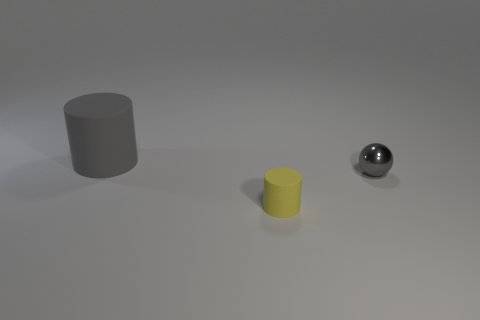Is there anything else that has the same material as the small sphere?
Offer a terse response. No. What color is the thing to the right of the matte thing that is right of the matte thing behind the gray ball?
Ensure brevity in your answer.  Gray. Is the small cylinder made of the same material as the object to the right of the tiny yellow rubber cylinder?
Keep it short and to the point. No. There is another thing that is the same shape as the yellow rubber thing; what is its size?
Ensure brevity in your answer.  Large. Is the number of tiny yellow matte cylinders that are on the left side of the gray matte thing the same as the number of gray metal balls that are behind the shiny object?
Provide a succinct answer. Yes. What number of other objects are there of the same material as the tiny sphere?
Your answer should be very brief. 0. Are there an equal number of gray matte cylinders right of the small yellow rubber cylinder and objects?
Provide a short and direct response. No. There is a gray metal ball; is it the same size as the cylinder behind the yellow matte thing?
Your answer should be very brief. No. What is the shape of the object that is in front of the small gray metal ball?
Offer a very short reply. Cylinder. Are there any other things that have the same shape as the small gray metal thing?
Your answer should be compact. No. 